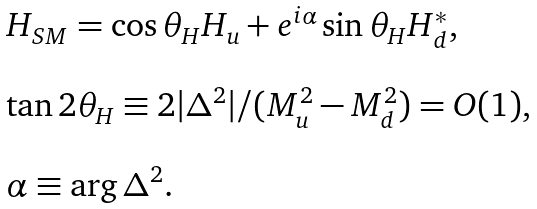Convert formula to latex. <formula><loc_0><loc_0><loc_500><loc_500>\begin{array} { l } H _ { S M } = \cos \theta _ { H } H _ { u } + e ^ { i \alpha } \sin \theta _ { H } H ^ { * } _ { d } , \\ \\ \tan 2 \theta _ { H } \equiv 2 | \Delta ^ { 2 } | / ( M _ { u } ^ { 2 } - M _ { d } ^ { 2 } ) = O ( 1 ) , \\ \\ \alpha \equiv \arg \Delta ^ { 2 } . \end{array}</formula> 